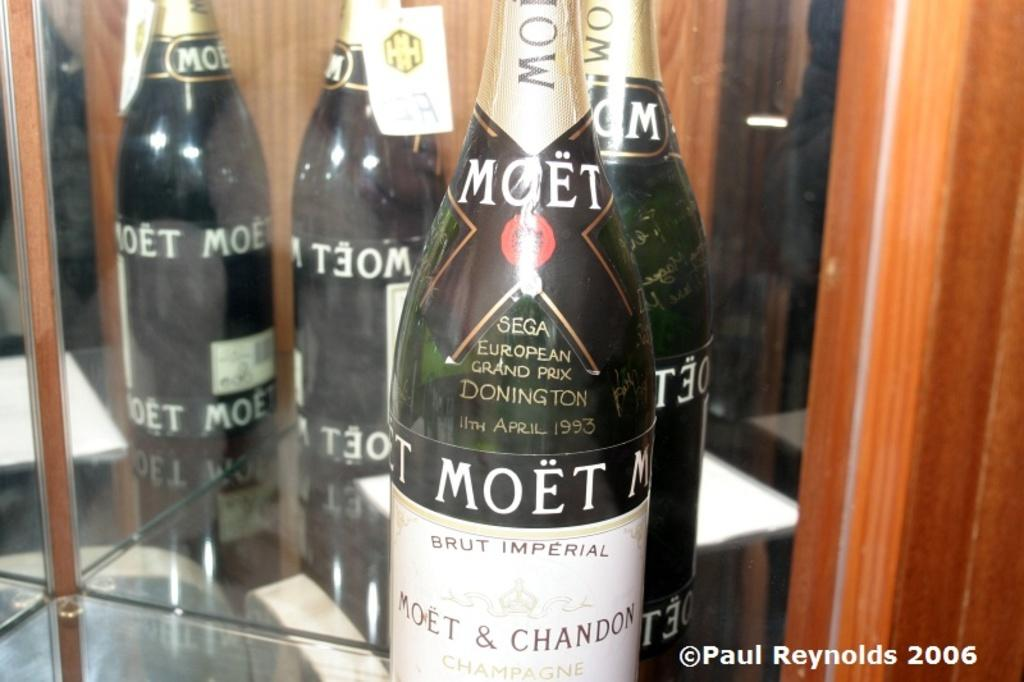<image>
Offer a succinct explanation of the picture presented. a bottle that has the word moet on it 